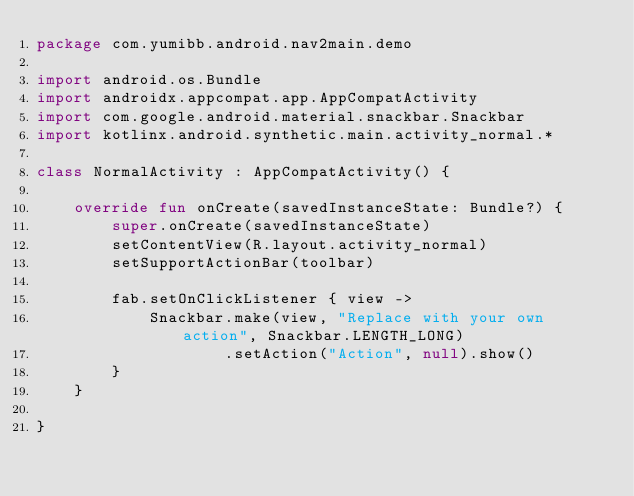Convert code to text. <code><loc_0><loc_0><loc_500><loc_500><_Kotlin_>package com.yumibb.android.nav2main.demo

import android.os.Bundle
import androidx.appcompat.app.AppCompatActivity
import com.google.android.material.snackbar.Snackbar
import kotlinx.android.synthetic.main.activity_normal.*

class NormalActivity : AppCompatActivity() {

    override fun onCreate(savedInstanceState: Bundle?) {
        super.onCreate(savedInstanceState)
        setContentView(R.layout.activity_normal)
        setSupportActionBar(toolbar)

        fab.setOnClickListener { view ->
            Snackbar.make(view, "Replace with your own action", Snackbar.LENGTH_LONG)
                    .setAction("Action", null).show()
        }
    }

}
</code> 